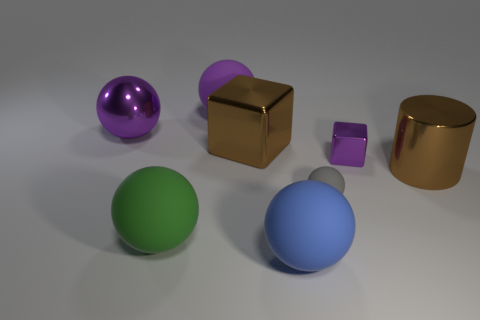Subtract all red balls. Subtract all brown blocks. How many balls are left? 5 Add 1 large purple rubber cubes. How many objects exist? 9 Subtract all blocks. How many objects are left? 6 Subtract 0 yellow spheres. How many objects are left? 8 Subtract all large shiny cylinders. Subtract all metal cubes. How many objects are left? 5 Add 4 large spheres. How many large spheres are left? 8 Add 5 small gray matte spheres. How many small gray matte spheres exist? 6 